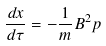<formula> <loc_0><loc_0><loc_500><loc_500>\frac { d { x } } { d \tau } = - \frac { 1 } { m } B ^ { 2 } { p }</formula> 